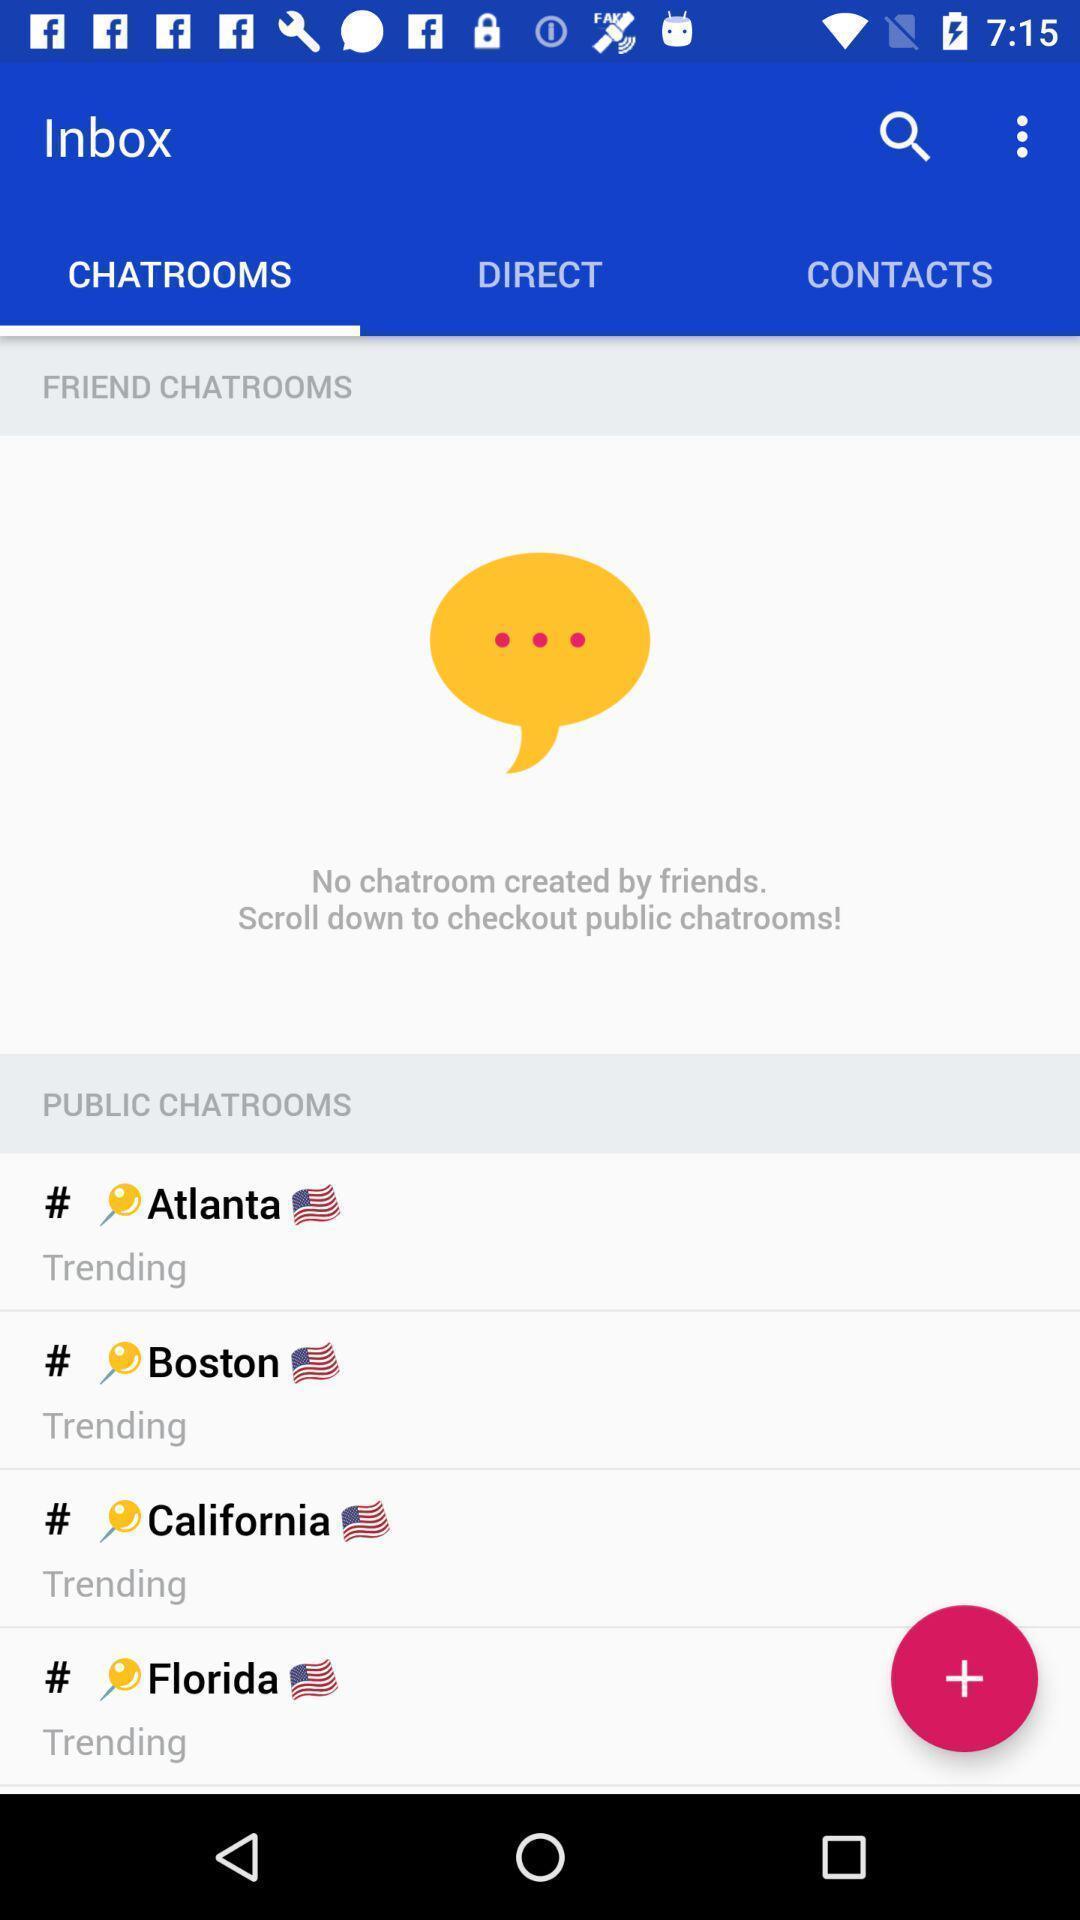Provide a description of this screenshot. Screen displaying the listings in chatrooms tab. 